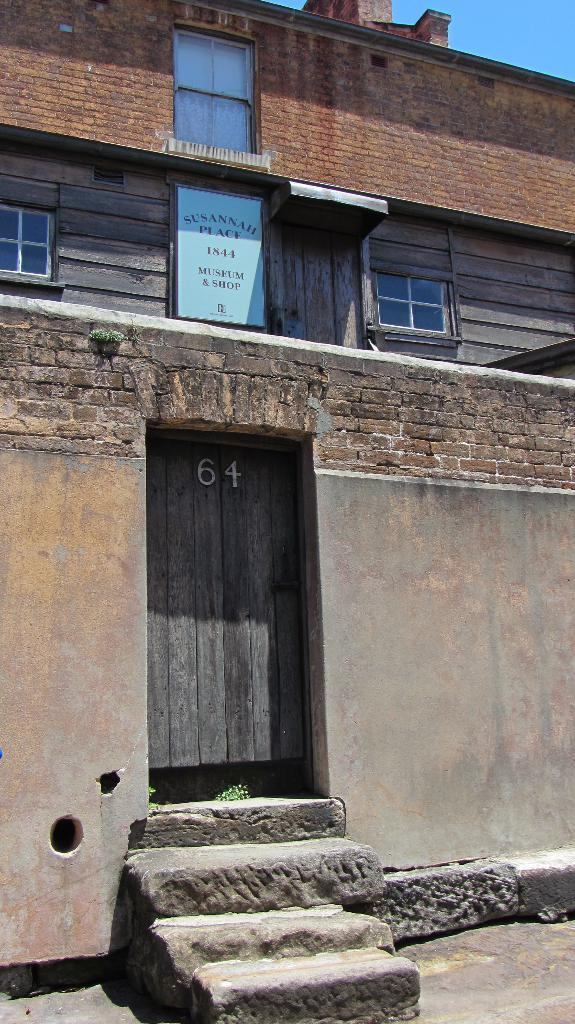What type of structure is present in the image? There is a building in the image. What features can be observed on the building? The building has windows and a door. Are there any other objects or elements in the image besides the building? Yes, there are other objects in the image. What can be seen in the background of the image? The sky is visible in the background of the image. How does the earthquake affect the building in the image? There is no earthquake present in the image, so its effect on the building cannot be determined. What type of mitten is being used to hold the door of the building in the image? There is no mitten present in the image, and the door is not being held by any object. 